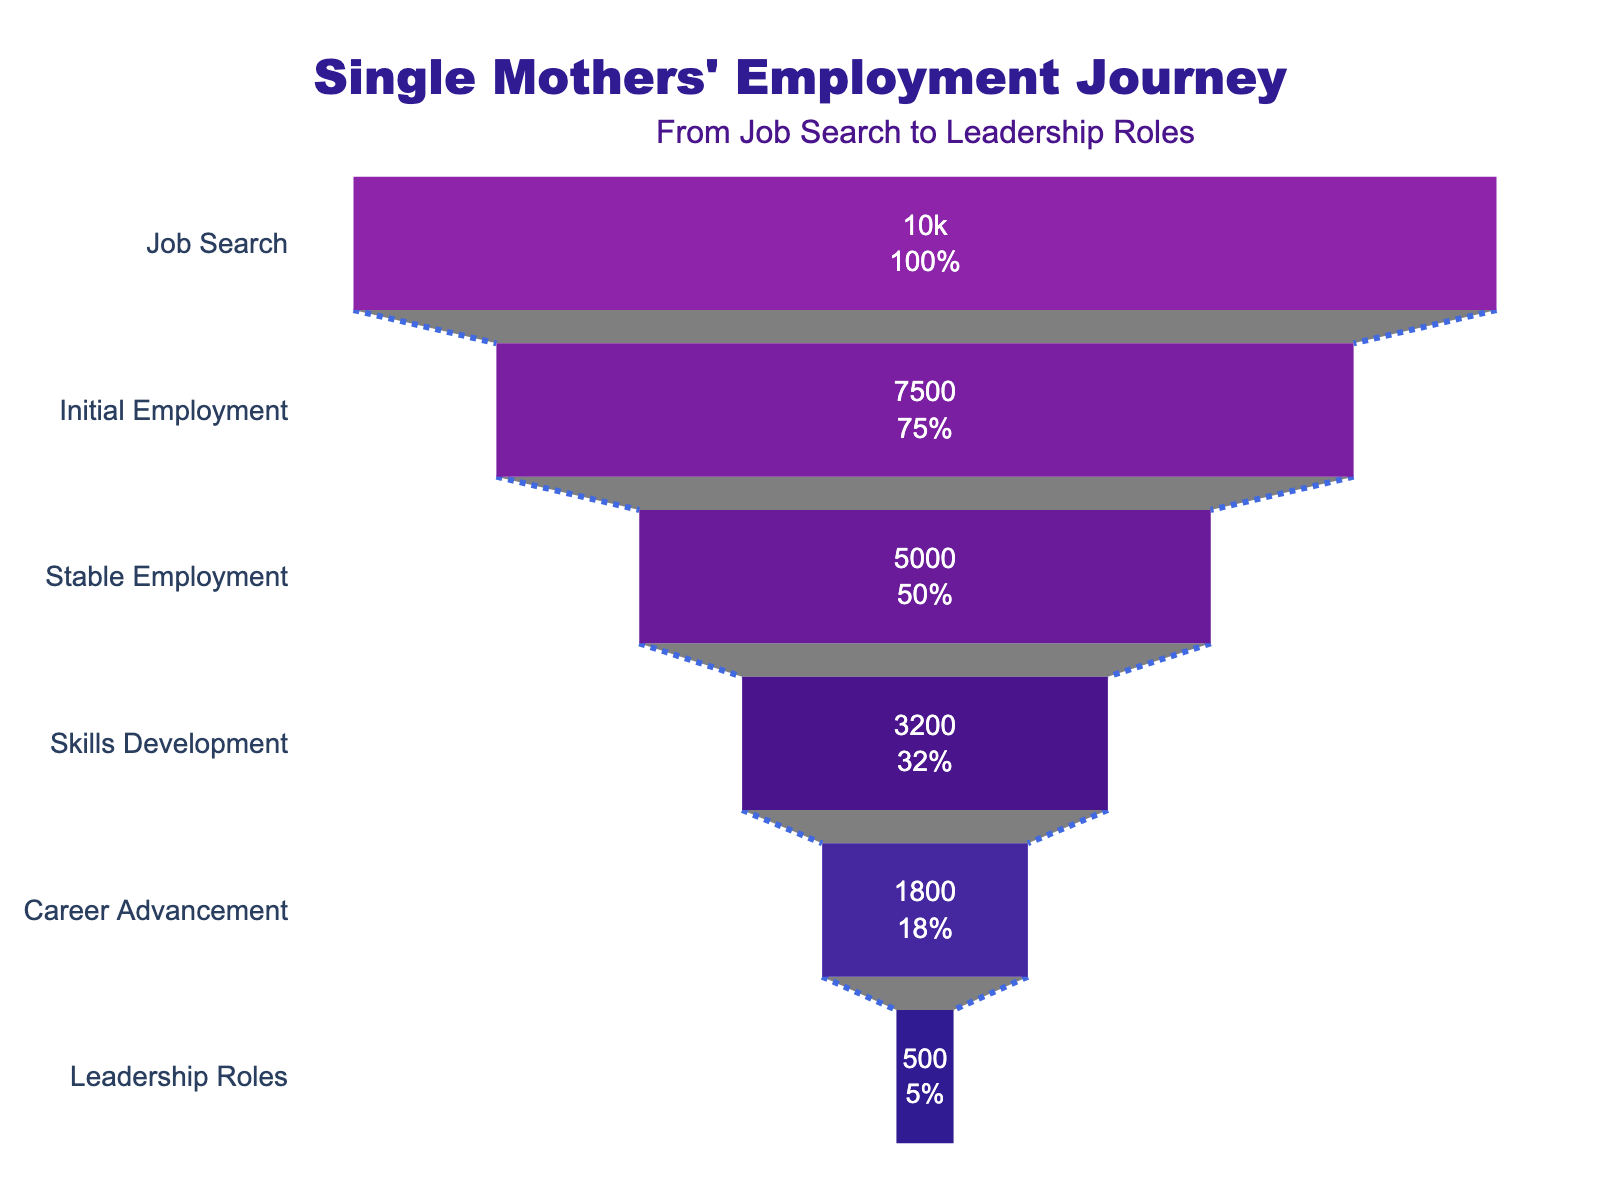How many single mothers are in the "Stable Employment" stage? The "Stable Employment" stage shows 5000 single mothers.
Answer: 5000 What percentage of single mothers move from "Job Search" to "Initial Employment"? The "Job Search" stage has 10000 single mothers, and the "Initial Employment" stage has 7500. The percentage is calculated as (7500 / 10000) * 100.
Answer: 75% Which stage has the smallest number of single mothers? The "Leadership Roles" stage shows the smallest number of single mothers, with a count of 500.
Answer: Leadership Roles How many single mothers advance from "Skills Development" to "Career Advancement"? The "Skills Development" stage has 3200 single mothers, and the "Career Advancement" stage has 1800. The advancement number is 3200 - 1800.
Answer: 1400 What is the total number of single mothers who achieve "Leadership Roles" out of those who started at the "Job Search" stage? From the "Job Search" stage (10000), 500 single mothers achieve "Leadership Roles".
Answer: 500 Calculate the retention rate from "Stable Employment" to "Skills Development". The "Stable Employment" stage has 5000 single mothers, and the "Skills Development" stage has 3200. The retention rate is calculated as (3200 / 5000) * 100.
Answer: 64% Compare the number of single mothers in "Career Advancement" with those in "Skills Development". The "Career Advancement" stage has 1800 single mothers, whereas the "Skills Development" stage has 3200.
Answer: Skills Development has more By what percentage does the number of single mothers decrease from "Career Advancement" to "Leadership Roles"? The "Career Advancement" stage has 1800 single mothers and the "Leadership Roles" stage has 500. The percentage decrease is ((1800 - 500) / 1800) * 100.
Answer: 72.2% What proportion of single mothers reach the "Skills Development" stage starting from "Job Search"? From the "Job Search" stage (10000), 3200 reach the "Skills Development" stage. The proportion is 3200 / 10000.
Answer: 0.32 How many stages are in the single mothers' employment journey? The funnel chart lists six stages: "Job Search," "Initial Employment," "Stable Employment," "Skills Development," "Career Advancement," and "Leadership Roles".
Answer: 6 